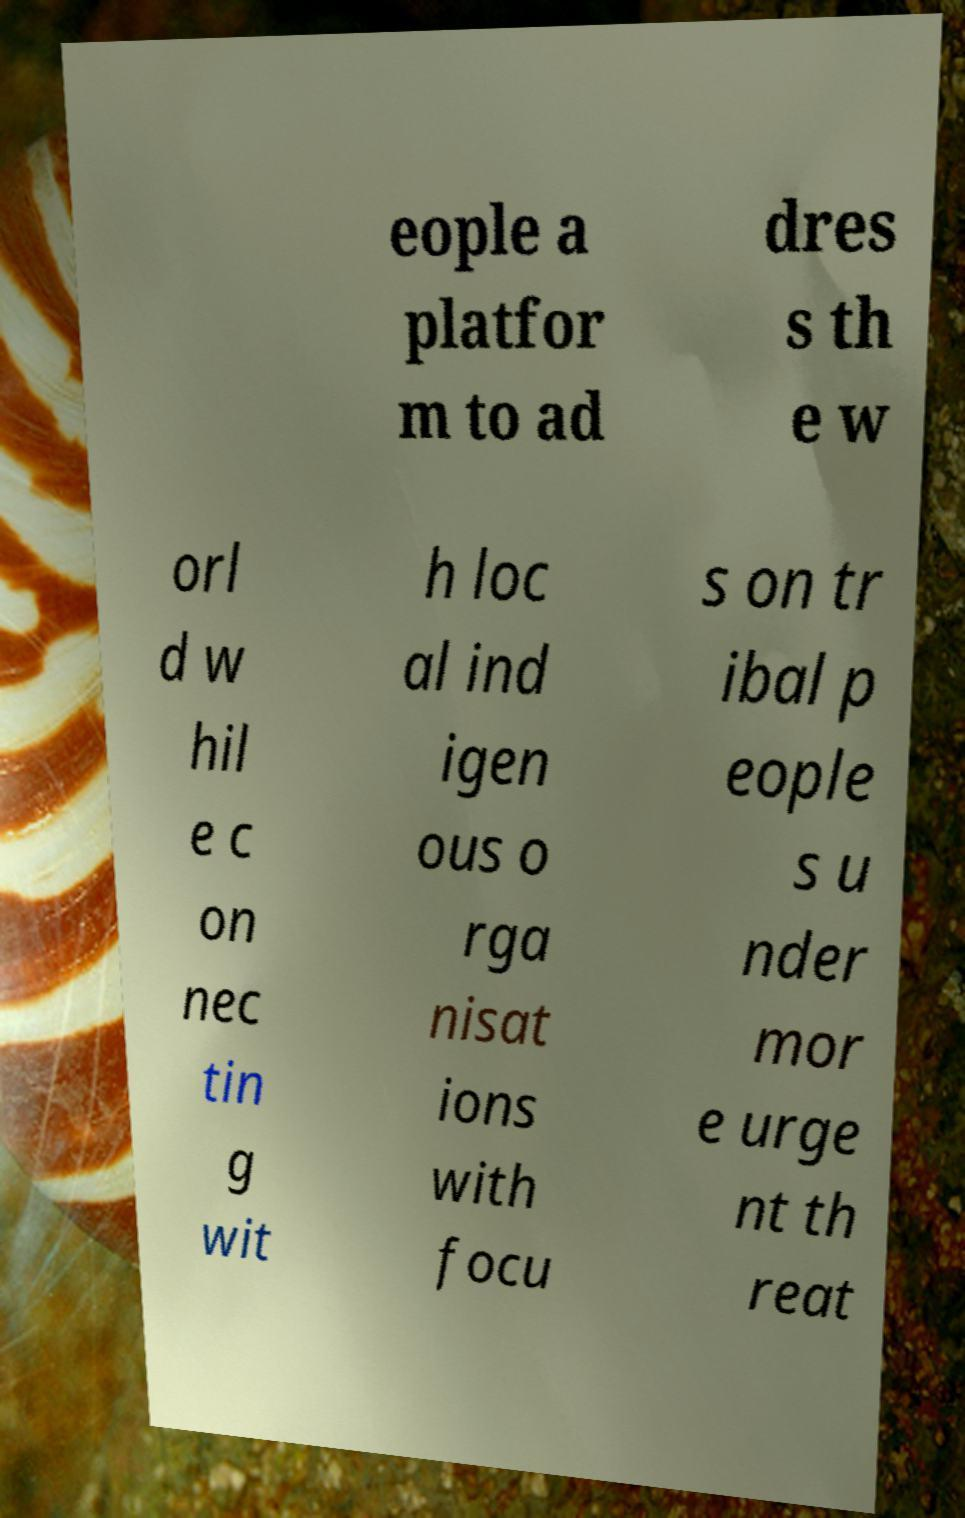Can you read and provide the text displayed in the image?This photo seems to have some interesting text. Can you extract and type it out for me? eople a platfor m to ad dres s th e w orl d w hil e c on nec tin g wit h loc al ind igen ous o rga nisat ions with focu s on tr ibal p eople s u nder mor e urge nt th reat 